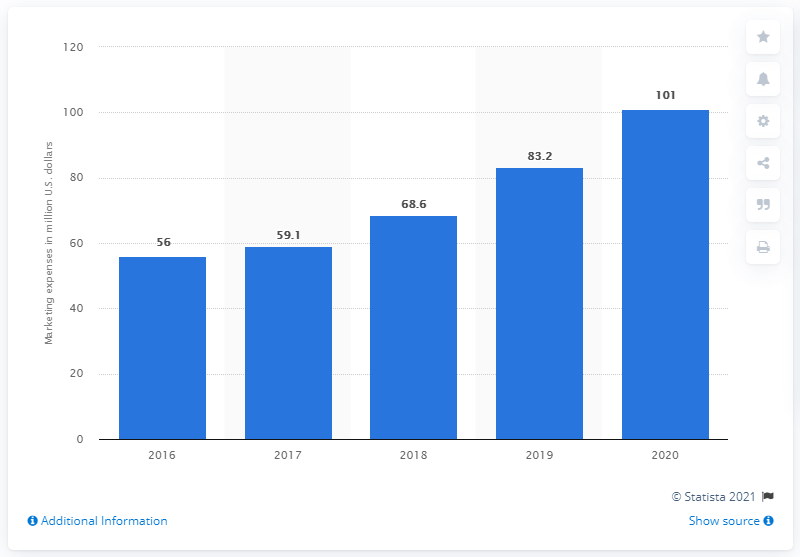Specify some key components in this picture. Crocs spent $59.1 million on marketing in 2017. In 2020, Crocs' global marketing expenses were $101 million. 